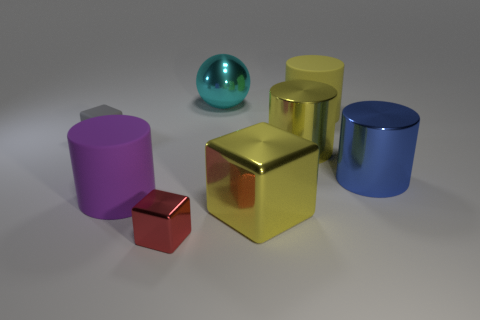Subtract all gray cylinders. Subtract all purple blocks. How many cylinders are left? 4 Add 2 big matte things. How many objects exist? 10 Subtract all cubes. How many objects are left? 5 Subtract 1 yellow cylinders. How many objects are left? 7 Subtract all big yellow cubes. Subtract all metal objects. How many objects are left? 2 Add 7 large cyan shiny spheres. How many large cyan shiny spheres are left? 8 Add 2 tiny red things. How many tiny red things exist? 3 